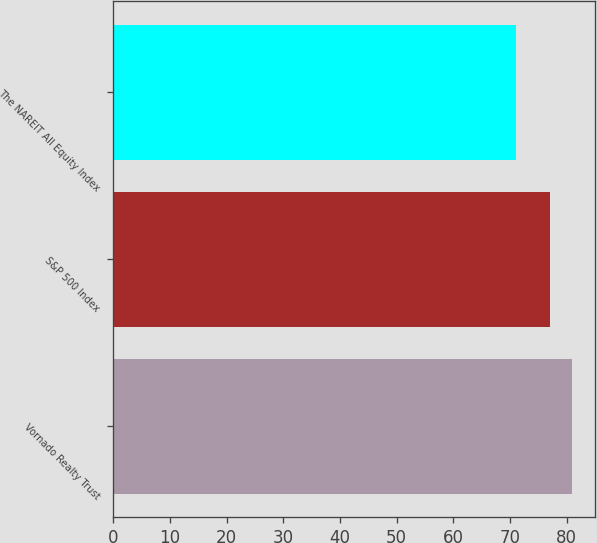<chart> <loc_0><loc_0><loc_500><loc_500><bar_chart><fcel>Vornado Realty Trust<fcel>S&P 500 Index<fcel>The NAREIT All Equity Index<nl><fcel>81<fcel>77<fcel>71<nl></chart> 